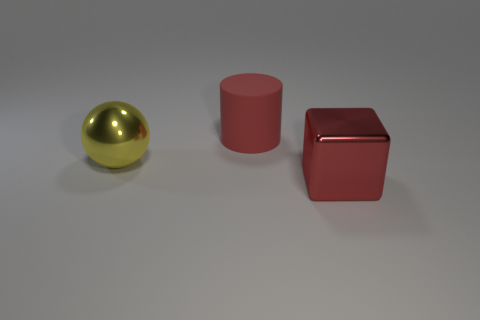Are there any red metal blocks that are behind the metal object that is left of the object that is behind the big yellow sphere?
Keep it short and to the point. No. Are any rubber cylinders visible?
Ensure brevity in your answer.  Yes. Are there more yellow shiny things that are in front of the ball than yellow spheres to the right of the red cube?
Your answer should be compact. No. The red block that is made of the same material as the big yellow sphere is what size?
Your answer should be very brief. Large. How big is the metallic thing that is right of the red object behind the metallic object that is right of the large rubber object?
Give a very brief answer. Large. What color is the big object on the left side of the red rubber cylinder?
Keep it short and to the point. Yellow. Are there more large metallic spheres in front of the yellow shiny object than large red shiny cylinders?
Your answer should be compact. No. Is the shape of the large metal thing left of the large metal block the same as  the red rubber thing?
Provide a short and direct response. No. What number of cyan things are cubes or large rubber cylinders?
Make the answer very short. 0. Is the number of small yellow metallic blocks greater than the number of rubber things?
Your response must be concise. No. 